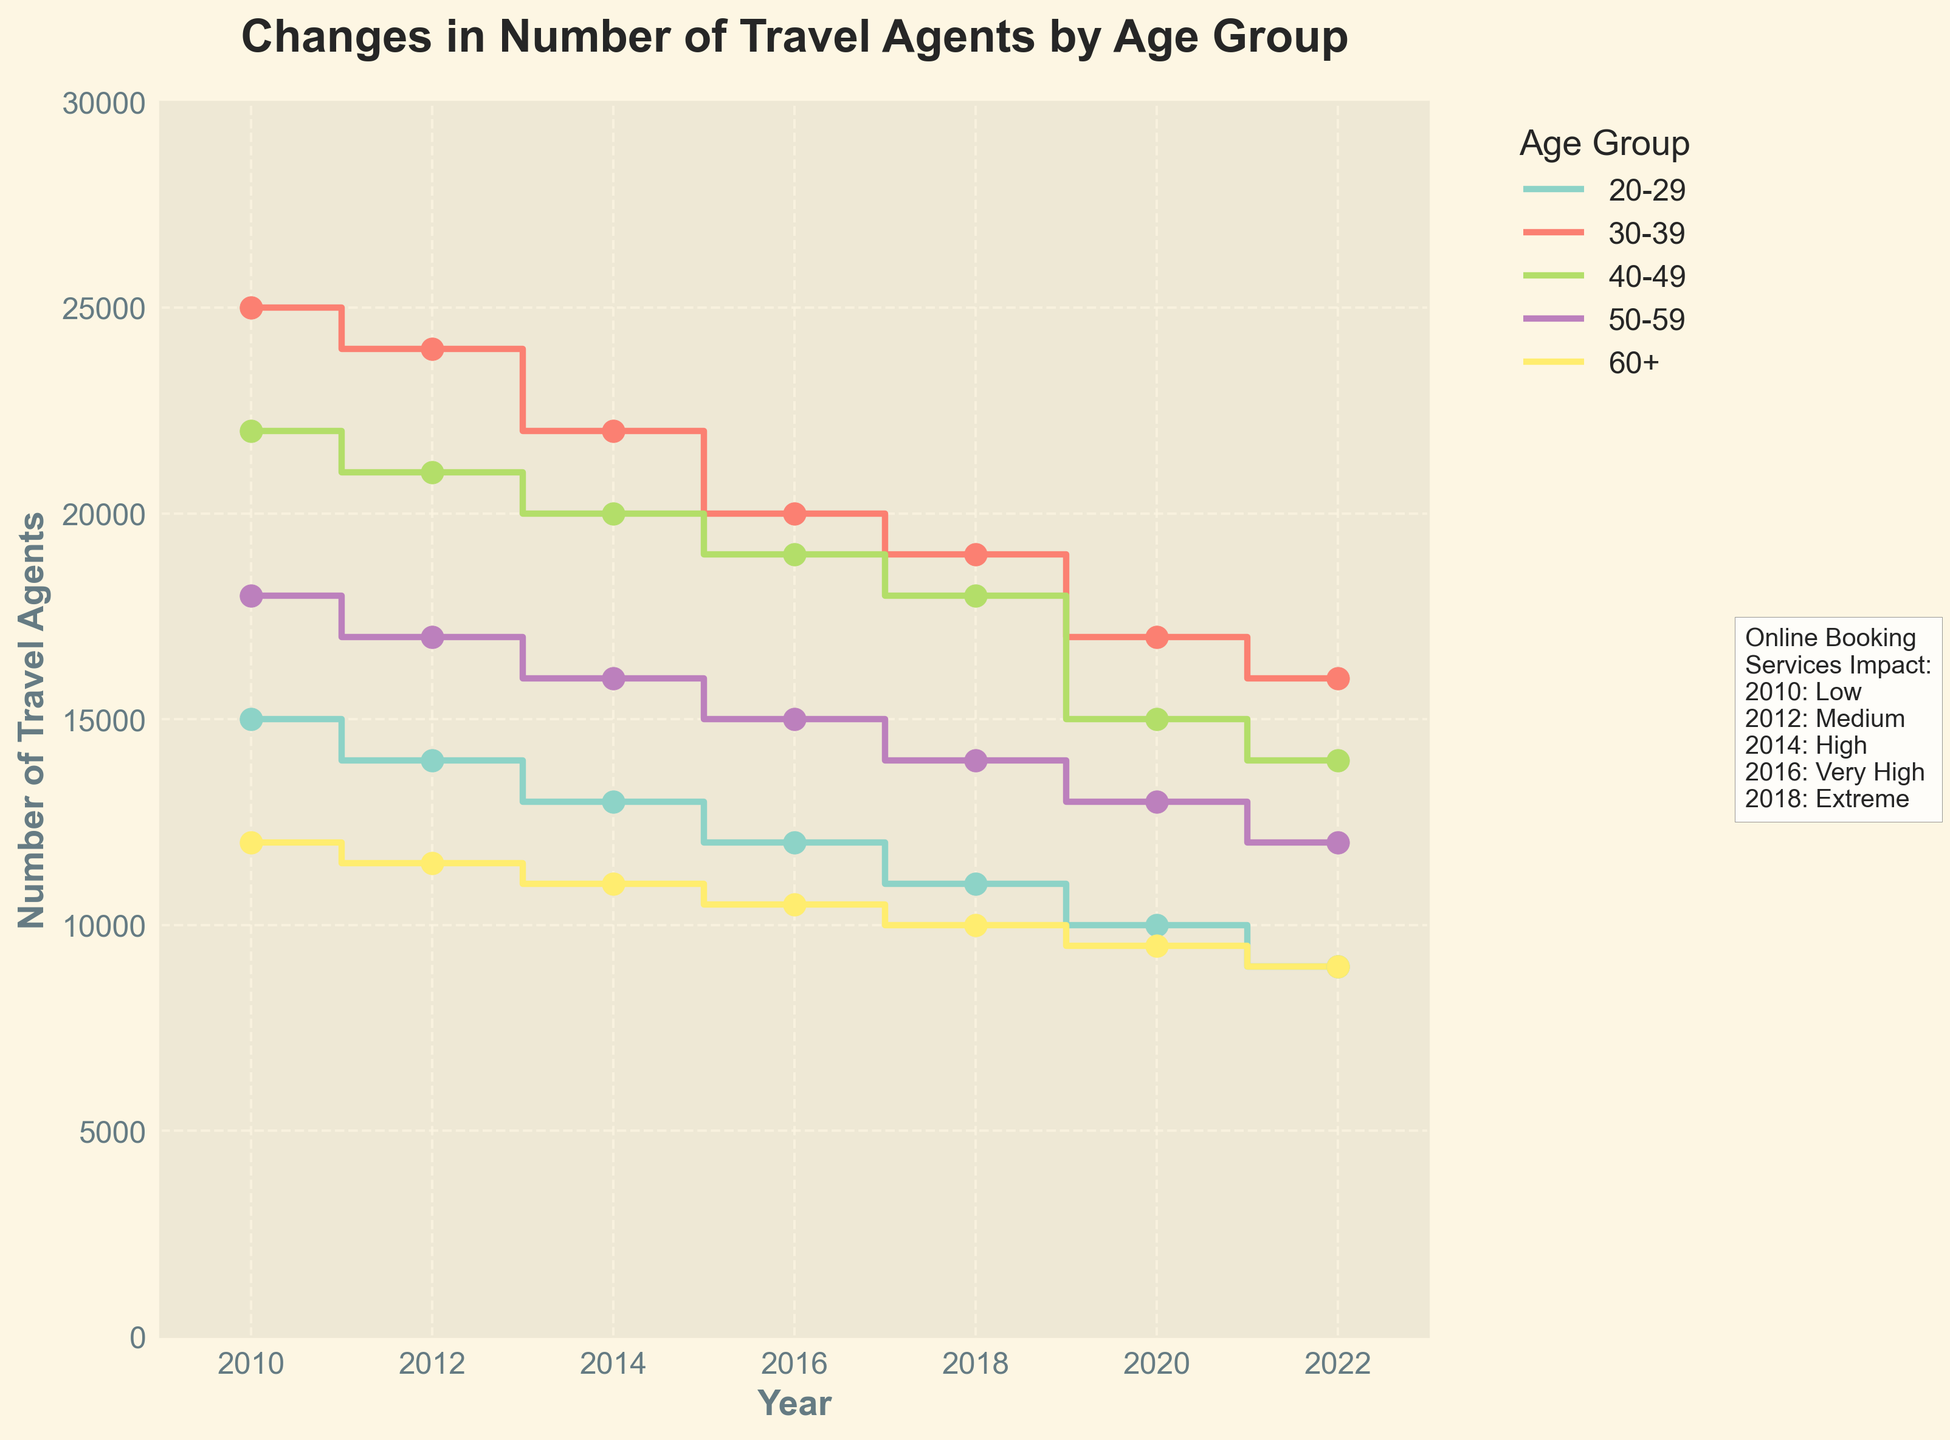How many age groups are represented in the figure? The figure shows lines and markers in different colors, each representing a distinct age group, which can be counted visually.
Answer: 5 Which age group had the largest number of travel agents in 2022? By observing the lines and their respective positions on the y-axis in 2022, we can determine which age group reached the highest point.
Answer: 30-39 How did the number of travel agents in the 20-29 age group change from 2010 to 2022? Look at the position of the line representing the 20-29 age group in 2010 and compare it to its position in 2022 on the plot to see the change.
Answer: Decreased by 6000 Which age group experienced the smallest decline in the number of travel agents between 2010 and 2022? Compare the vertical distance (decline) of each age group's line from 2010 to 2022 to find the smallest reduction.
Answer: 60+ In which year did the number of travel agents begin to significantly decline across all age groups? Identify the year where a noticeable drop occurs in the stair-step lines for all age groups.
Answer: 2014 What was the impact of online booking services in 2016? Check the annotation text placed beside the graph that lists the impact for each year.
Answer: Very High By how much did the number of travel agents in the 40-49 age group change between 2012 and 2018? Look at the numbers on the y-axis for the lines corresponding to the 40-49 age group in 2012 and 2018 and calculate the difference.
Answer: 3000 decrease Which age group had the most stable number of travel agents from 2010 to 2022? Assess the plot lines and observe which line shows the smallest variation or fluctuation over the years.
Answer: 60+ How is the trend of the number of travel agents in the 50-59 age group from 2010 to 2022? Track the plot line associated with the 50-59 age group from beginning to end, observing the overall direction and changes.
Answer: Decreasing What general trend can be observed about the number of travel agents in relation to the impact of online booking services? Compare the vertical positions of all the lines from 2010 to 2022 while referring to the textual information about the impact of online booking services.
Answer: Decline with increasing impact 